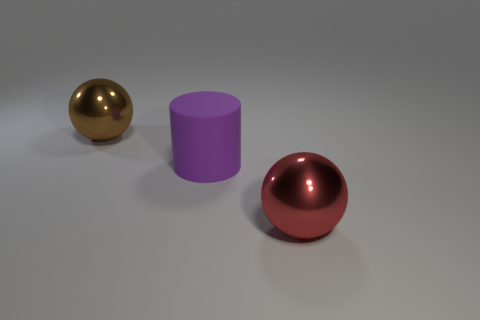Can you tell me what materials the objects in the image might be made of? The sphere on the left appears to have a reflective metallic surface, possibly representing a material like bronze or brass. The cylinder in the center has a matte finish, suggesting it could be made of a material like plastic or painted metal. Finally, the sphere on the right also has a reflective surface and could be a painted metal, similar to the material of the left sphere but in a different color. 